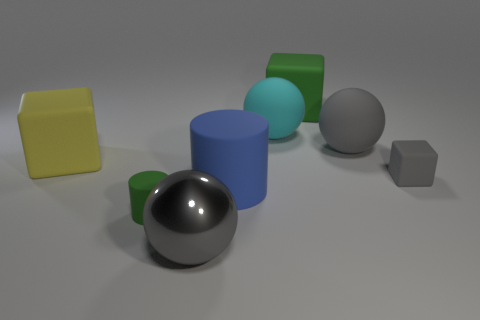Subtract all brown cylinders. Subtract all cyan balls. How many cylinders are left? 2 Add 2 yellow matte things. How many objects exist? 10 Subtract all spheres. How many objects are left? 5 Subtract 0 brown blocks. How many objects are left? 8 Subtract all large yellow metal blocks. Subtract all yellow objects. How many objects are left? 7 Add 6 large green things. How many large green things are left? 7 Add 3 tiny matte cylinders. How many tiny matte cylinders exist? 4 